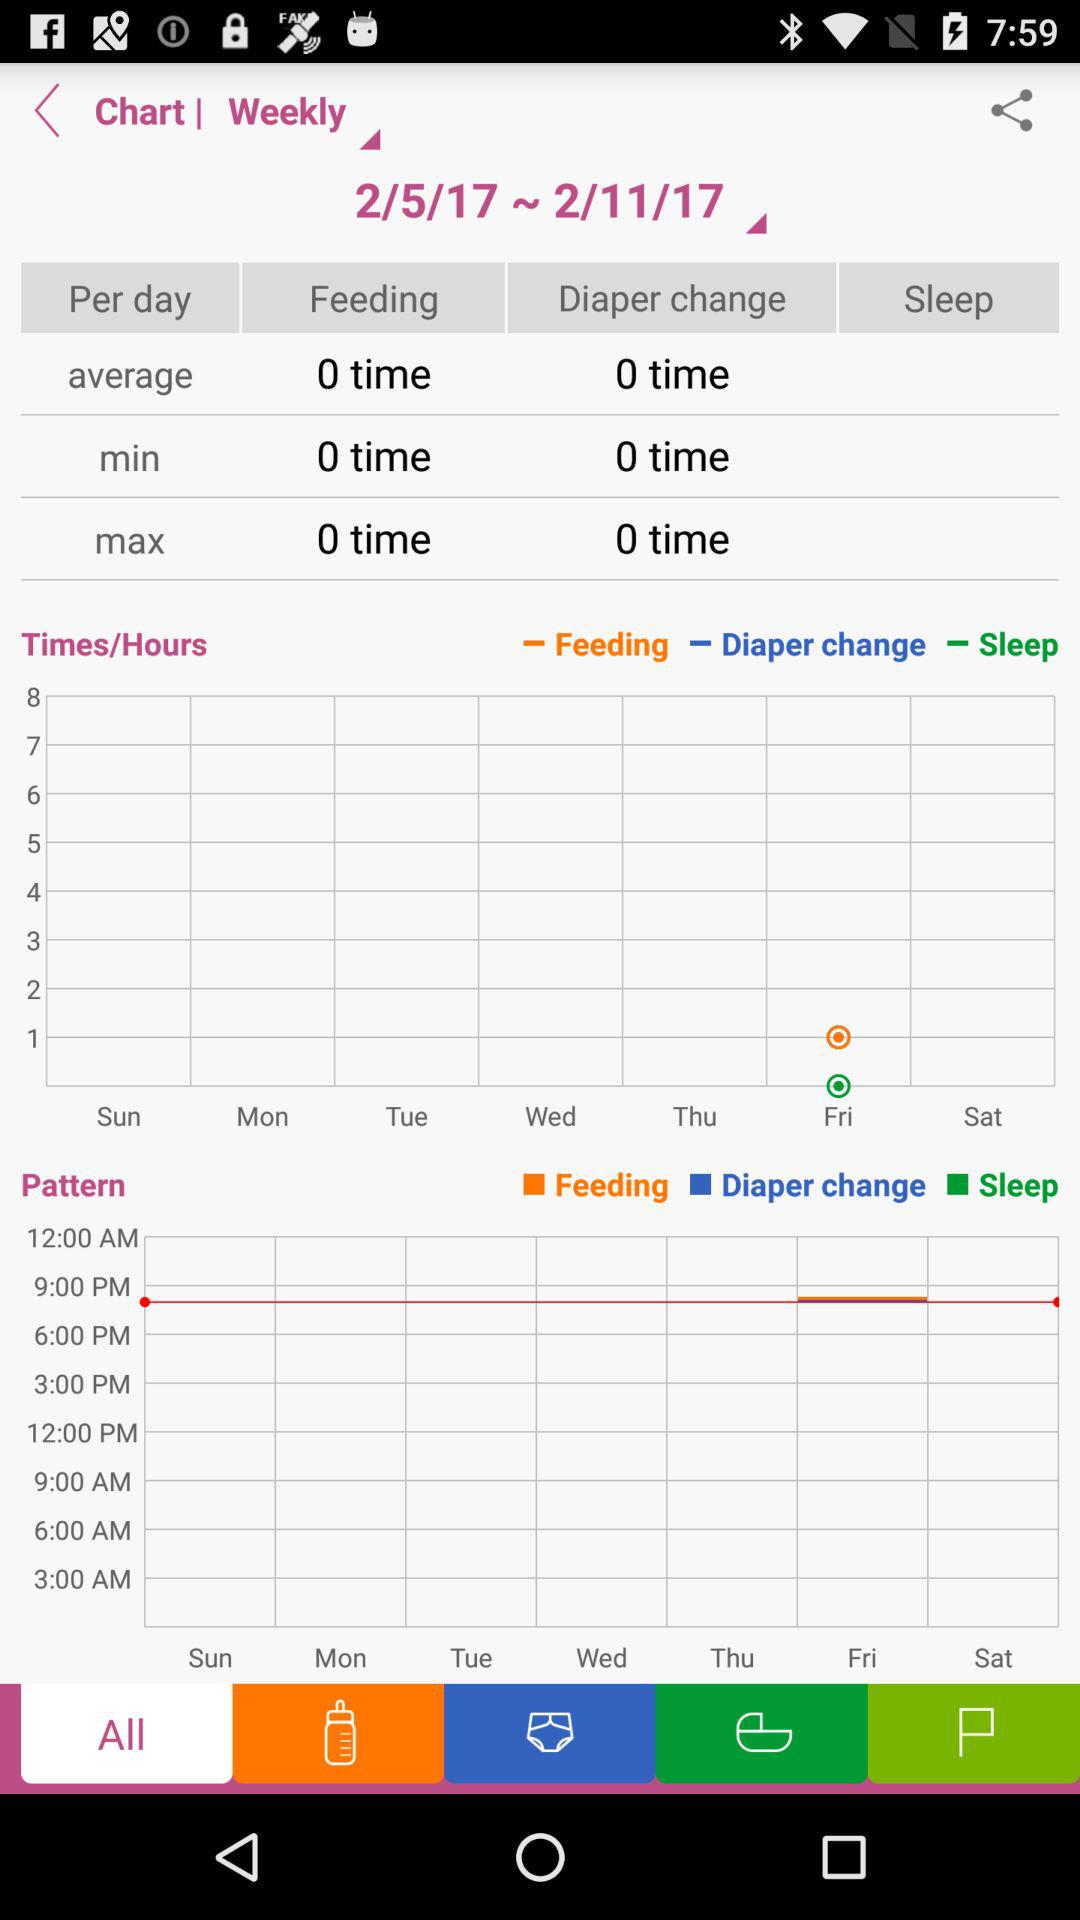What is the average number of feedings? The average number of feedings is 0. 